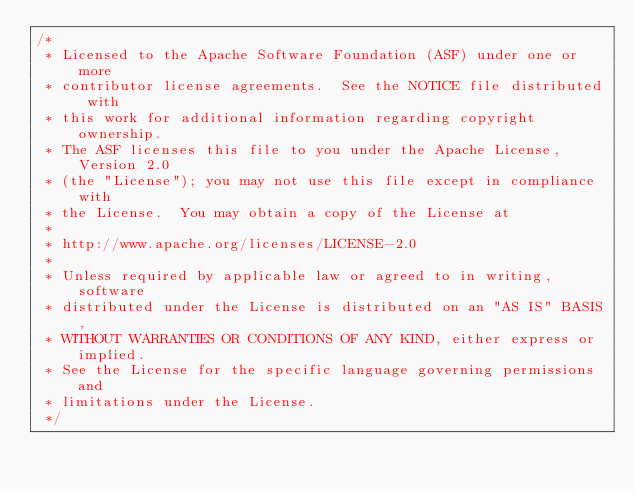Convert code to text. <code><loc_0><loc_0><loc_500><loc_500><_Java_>/*
 * Licensed to the Apache Software Foundation (ASF) under one or more
 * contributor license agreements.  See the NOTICE file distributed with
 * this work for additional information regarding copyright ownership.
 * The ASF licenses this file to you under the Apache License, Version 2.0
 * (the "License"); you may not use this file except in compliance with
 * the License.  You may obtain a copy of the License at
 *
 * http://www.apache.org/licenses/LICENSE-2.0
 *
 * Unless required by applicable law or agreed to in writing, software
 * distributed under the License is distributed on an "AS IS" BASIS,
 * WITHOUT WARRANTIES OR CONDITIONS OF ANY KIND, either express or implied.
 * See the License for the specific language governing permissions and
 * limitations under the License.
 */</code> 